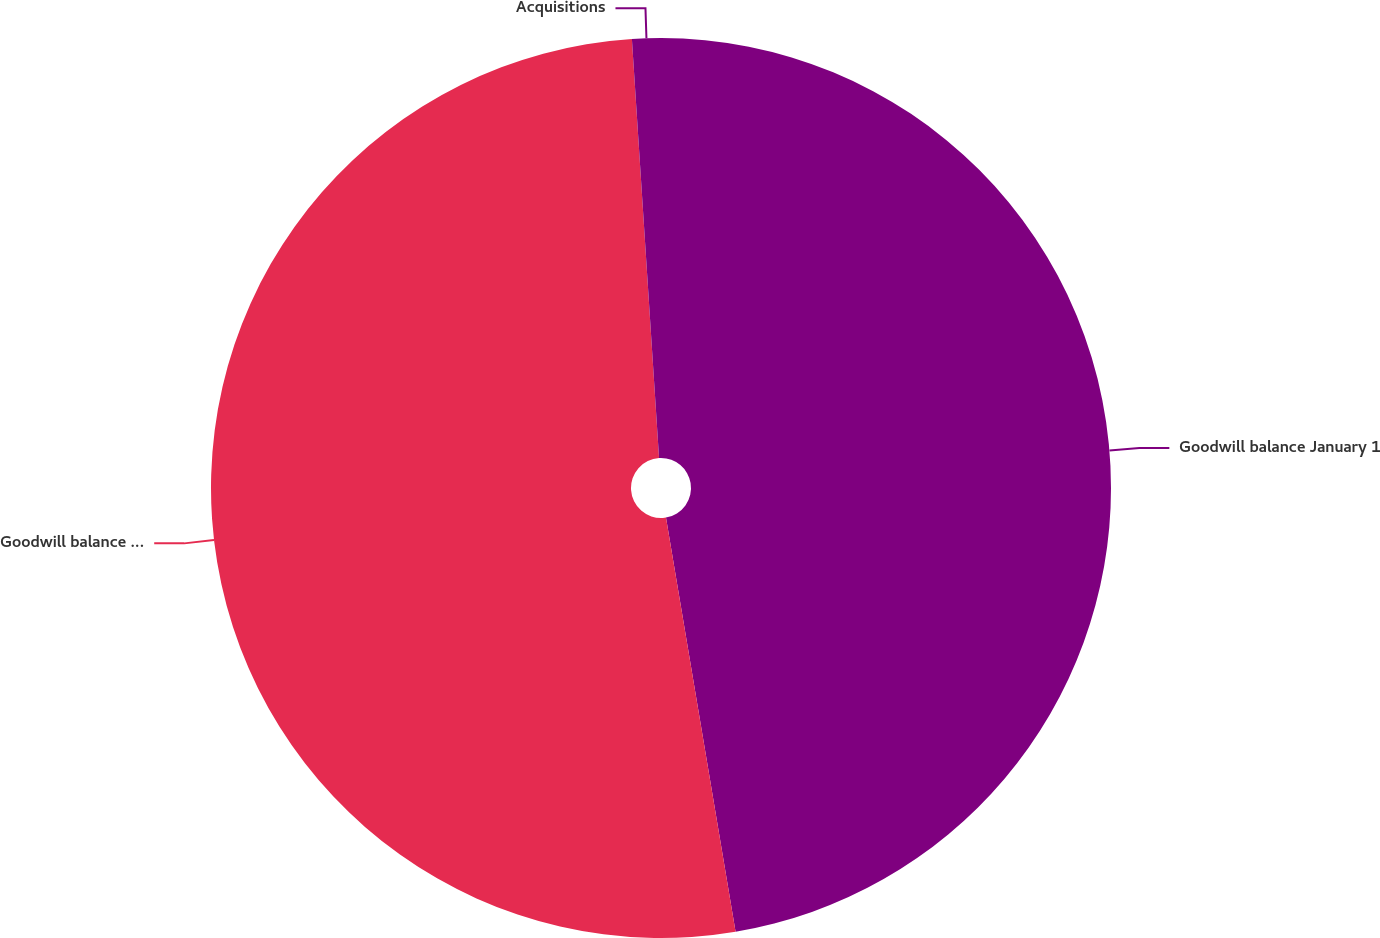Convert chart to OTSL. <chart><loc_0><loc_0><loc_500><loc_500><pie_chart><fcel>Goodwill balance January 1<fcel>Goodwill balance December 31<fcel>Acquisitions<nl><fcel>47.35%<fcel>51.62%<fcel>1.03%<nl></chart> 